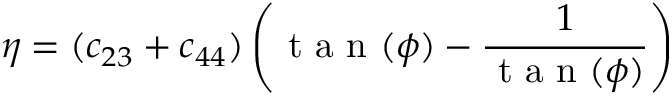<formula> <loc_0><loc_0><loc_500><loc_500>\eta = ( c _ { 2 3 } + c _ { 4 4 } ) \left ( t a n ( \phi ) - \frac { 1 } { t a n ( \phi ) } \right )</formula> 